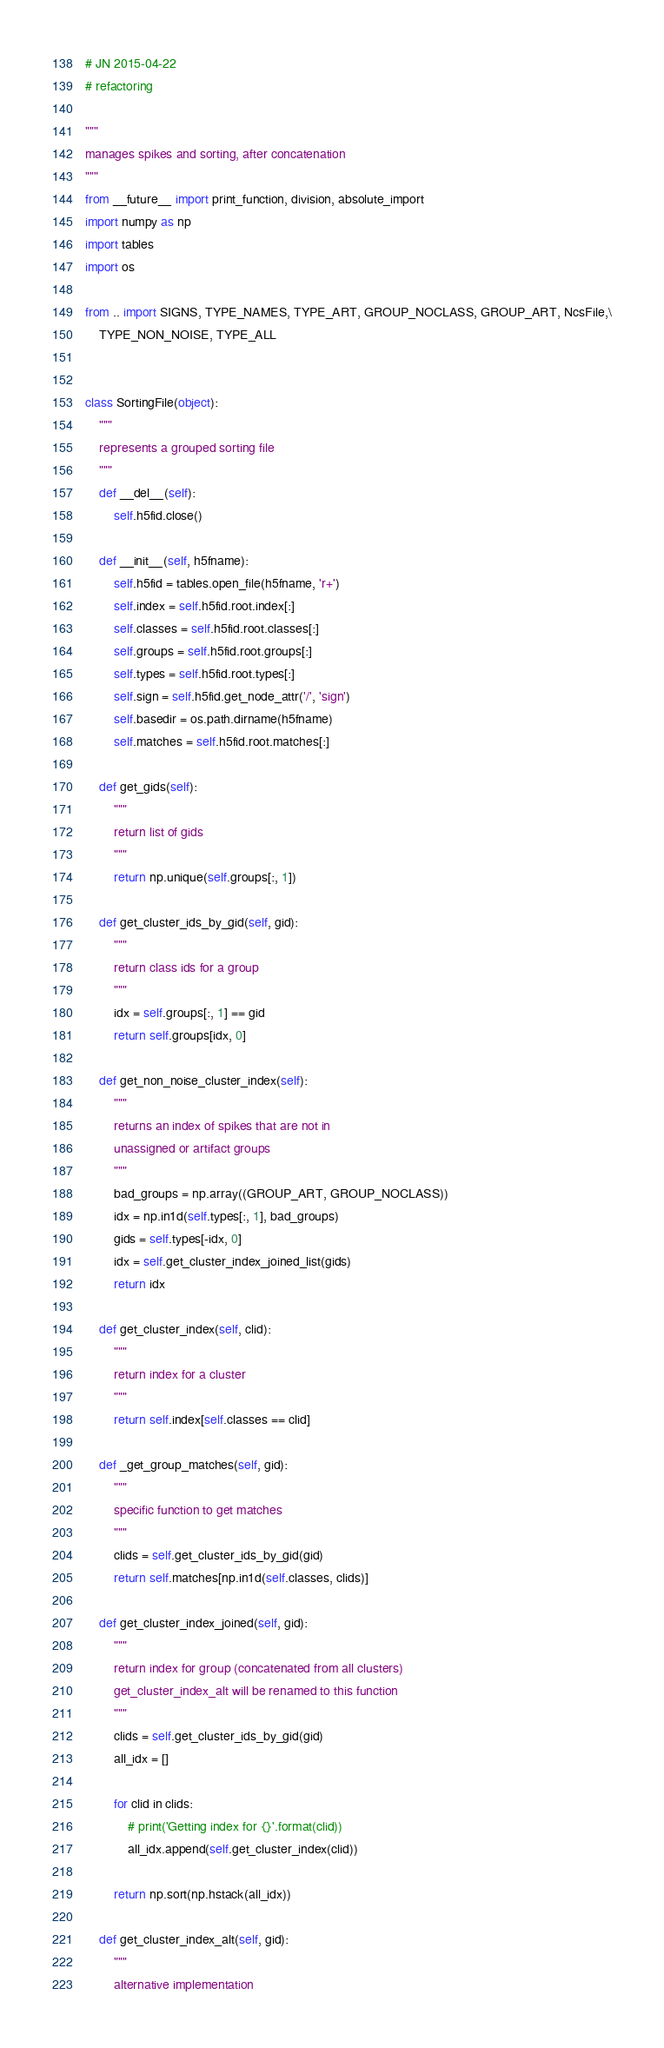Convert code to text. <code><loc_0><loc_0><loc_500><loc_500><_Python_># JN 2015-04-22
# refactoring

"""
manages spikes and sorting, after concatenation
"""
from __future__ import print_function, division, absolute_import
import numpy as np
import tables
import os

from .. import SIGNS, TYPE_NAMES, TYPE_ART, GROUP_NOCLASS, GROUP_ART, NcsFile,\
    TYPE_NON_NOISE, TYPE_ALL


class SortingFile(object):
    """
    represents a grouped sorting file
    """
    def __del__(self):
        self.h5fid.close()

    def __init__(self, h5fname):
        self.h5fid = tables.open_file(h5fname, 'r+')
        self.index = self.h5fid.root.index[:]
        self.classes = self.h5fid.root.classes[:]
        self.groups = self.h5fid.root.groups[:]
        self.types = self.h5fid.root.types[:]
        self.sign = self.h5fid.get_node_attr('/', 'sign')
        self.basedir = os.path.dirname(h5fname)
        self.matches = self.h5fid.root.matches[:]

    def get_gids(self):
        """
        return list of gids
        """
        return np.unique(self.groups[:, 1])

    def get_cluster_ids_by_gid(self, gid):
        """
        return class ids for a group
        """
        idx = self.groups[:, 1] == gid
        return self.groups[idx, 0]

    def get_non_noise_cluster_index(self):
        """
        returns an index of spikes that are not in
        unassigned or artifact groups
        """
        bad_groups = np.array((GROUP_ART, GROUP_NOCLASS))
        idx = np.in1d(self.types[:, 1], bad_groups)
        gids = self.types[-idx, 0]
        idx = self.get_cluster_index_joined_list(gids)
        return idx

    def get_cluster_index(self, clid):
        """
        return index for a cluster
        """
        return self.index[self.classes == clid]

    def _get_group_matches(self, gid):
        """
        specific function to get matches
        """
        clids = self.get_cluster_ids_by_gid(gid)
        return self.matches[np.in1d(self.classes, clids)]

    def get_cluster_index_joined(self, gid):
        """
        return index for group (concatenated from all clusters)
        get_cluster_index_alt will be renamed to this function
        """
        clids = self.get_cluster_ids_by_gid(gid)
        all_idx = []

        for clid in clids:
            # print('Getting index for {}'.format(clid))
            all_idx.append(self.get_cluster_index(clid))

        return np.sort(np.hstack(all_idx))

    def get_cluster_index_alt(self, gid):
        """
        alternative implementation</code> 